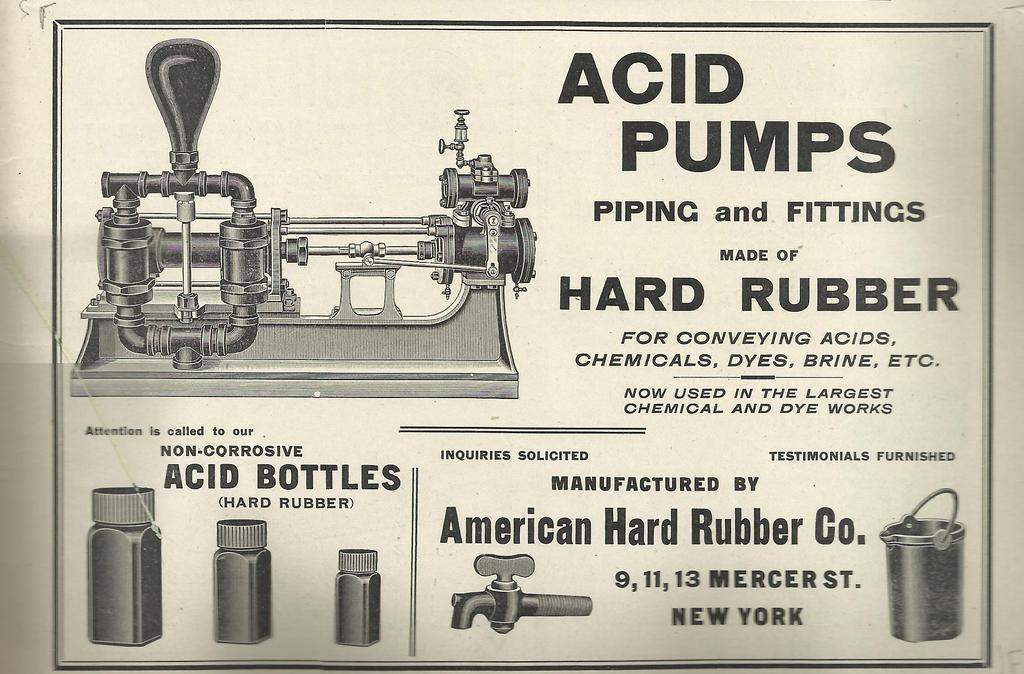<image>
Create a compact narrative representing the image presented. An advertisement for Acid Pumps that are made out of hard rubber. 